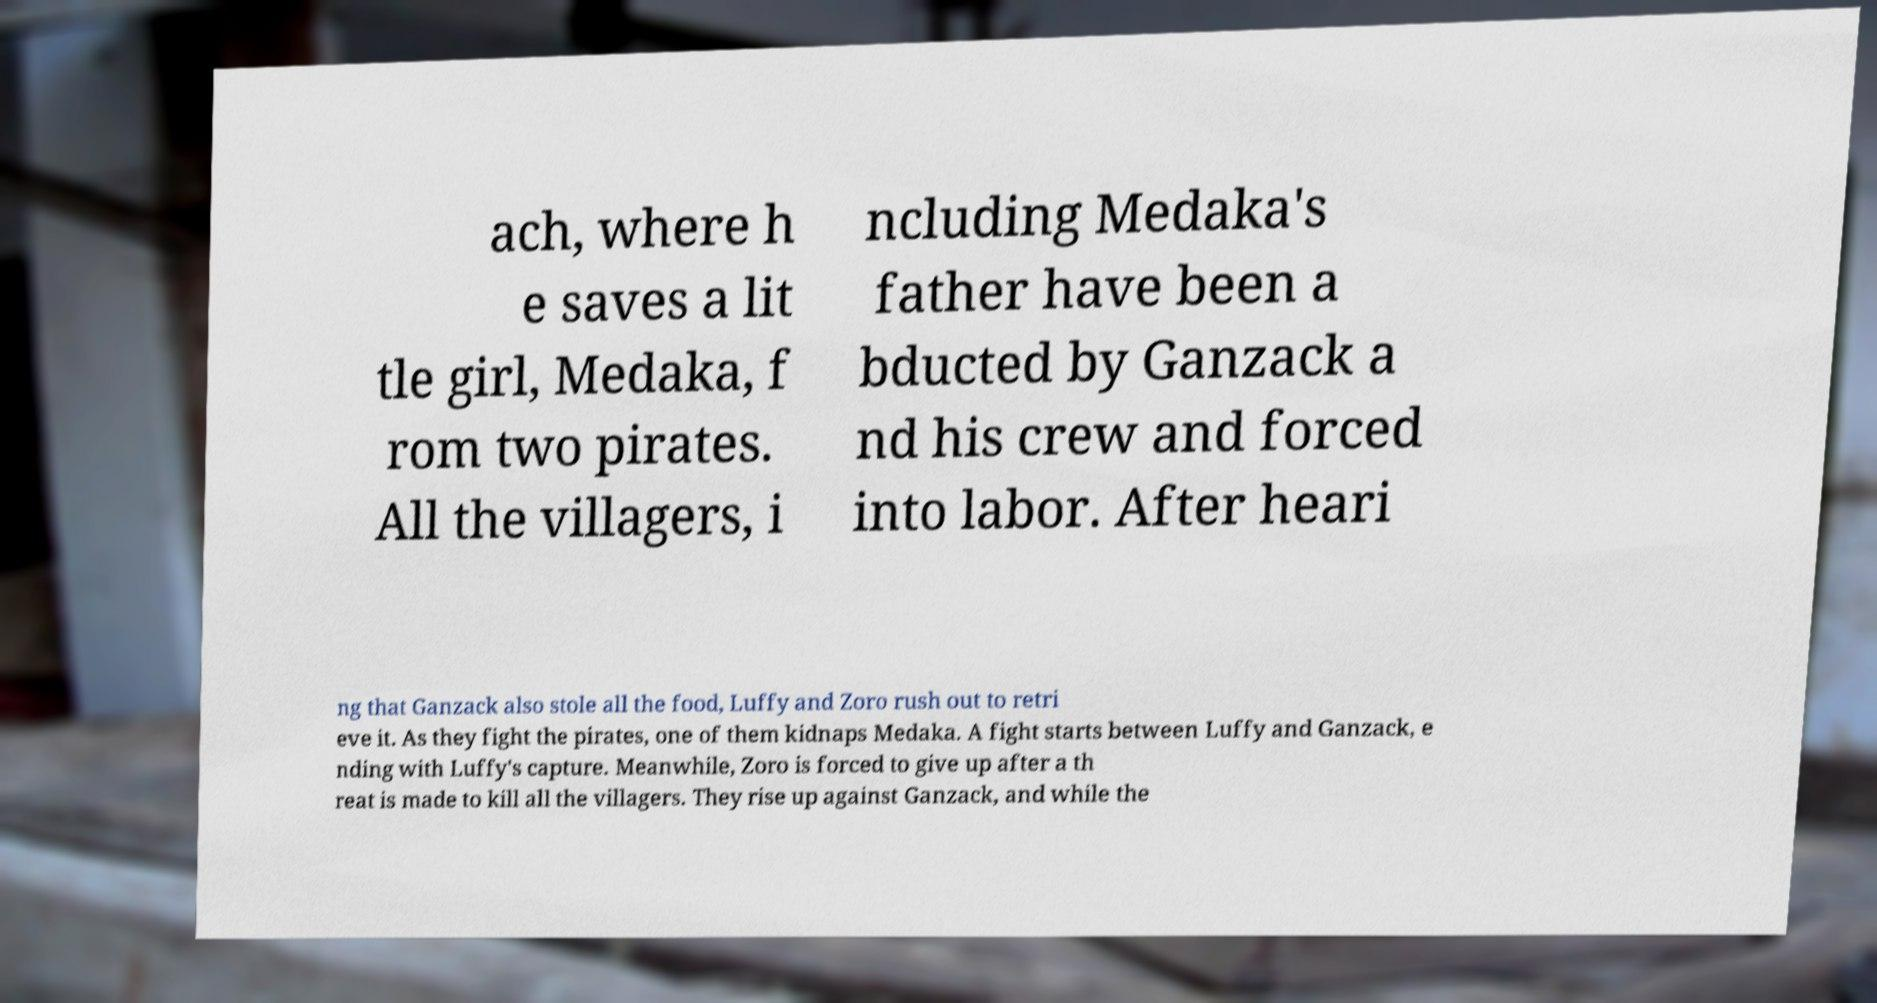Could you extract and type out the text from this image? ach, where h e saves a lit tle girl, Medaka, f rom two pirates. All the villagers, i ncluding Medaka's father have been a bducted by Ganzack a nd his crew and forced into labor. After heari ng that Ganzack also stole all the food, Luffy and Zoro rush out to retri eve it. As they fight the pirates, one of them kidnaps Medaka. A fight starts between Luffy and Ganzack, e nding with Luffy's capture. Meanwhile, Zoro is forced to give up after a th reat is made to kill all the villagers. They rise up against Ganzack, and while the 